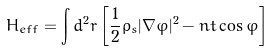Convert formula to latex. <formula><loc_0><loc_0><loc_500><loc_500>H _ { e f f } = \int d ^ { 2 } r \left [ \frac { 1 } { 2 } \rho _ { s } | \nabla \varphi | ^ { 2 } - n t \cos { \varphi } \right ]</formula> 